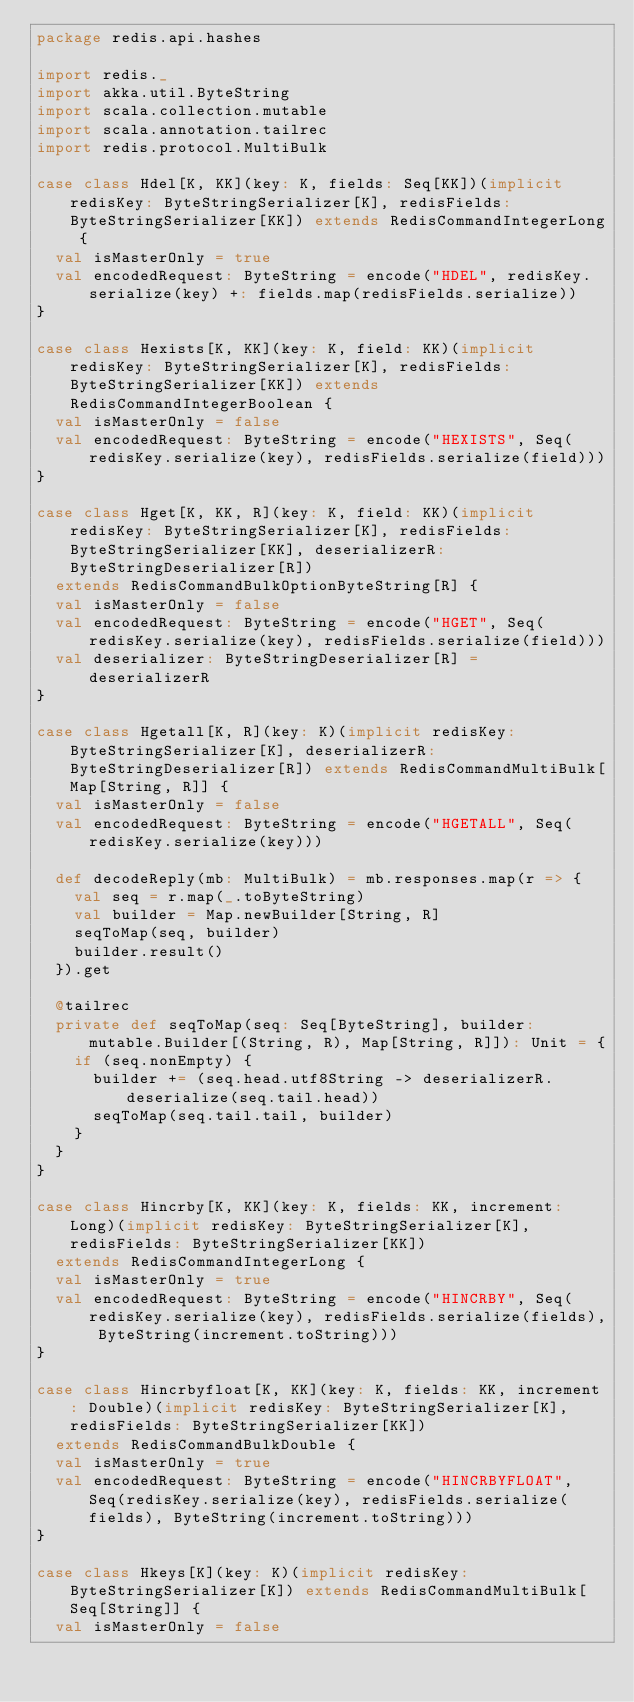<code> <loc_0><loc_0><loc_500><loc_500><_Scala_>package redis.api.hashes

import redis._
import akka.util.ByteString
import scala.collection.mutable
import scala.annotation.tailrec
import redis.protocol.MultiBulk

case class Hdel[K, KK](key: K, fields: Seq[KK])(implicit redisKey: ByteStringSerializer[K], redisFields: ByteStringSerializer[KK]) extends RedisCommandIntegerLong {
  val isMasterOnly = true
  val encodedRequest: ByteString = encode("HDEL", redisKey.serialize(key) +: fields.map(redisFields.serialize))
}

case class Hexists[K, KK](key: K, field: KK)(implicit redisKey: ByteStringSerializer[K], redisFields: ByteStringSerializer[KK]) extends RedisCommandIntegerBoolean {
  val isMasterOnly = false
  val encodedRequest: ByteString = encode("HEXISTS", Seq(redisKey.serialize(key), redisFields.serialize(field)))
}

case class Hget[K, KK, R](key: K, field: KK)(implicit redisKey: ByteStringSerializer[K], redisFields: ByteStringSerializer[KK], deserializerR: ByteStringDeserializer[R])
  extends RedisCommandBulkOptionByteString[R] {
  val isMasterOnly = false
  val encodedRequest: ByteString = encode("HGET", Seq(redisKey.serialize(key), redisFields.serialize(field)))
  val deserializer: ByteStringDeserializer[R] = deserializerR
}

case class Hgetall[K, R](key: K)(implicit redisKey: ByteStringSerializer[K], deserializerR: ByteStringDeserializer[R]) extends RedisCommandMultiBulk[Map[String, R]] {
  val isMasterOnly = false
  val encodedRequest: ByteString = encode("HGETALL", Seq(redisKey.serialize(key)))

  def decodeReply(mb: MultiBulk) = mb.responses.map(r => {
    val seq = r.map(_.toByteString)
    val builder = Map.newBuilder[String, R]
    seqToMap(seq, builder)
    builder.result()
  }).get

  @tailrec
  private def seqToMap(seq: Seq[ByteString], builder: mutable.Builder[(String, R), Map[String, R]]): Unit = {
    if (seq.nonEmpty) {
      builder += (seq.head.utf8String -> deserializerR.deserialize(seq.tail.head))
      seqToMap(seq.tail.tail, builder)
    }
  }
}

case class Hincrby[K, KK](key: K, fields: KK, increment: Long)(implicit redisKey: ByteStringSerializer[K], redisFields: ByteStringSerializer[KK])
  extends RedisCommandIntegerLong {
  val isMasterOnly = true
  val encodedRequest: ByteString = encode("HINCRBY", Seq(redisKey.serialize(key), redisFields.serialize(fields), ByteString(increment.toString)))
}

case class Hincrbyfloat[K, KK](key: K, fields: KK, increment: Double)(implicit redisKey: ByteStringSerializer[K], redisFields: ByteStringSerializer[KK])
  extends RedisCommandBulkDouble {
  val isMasterOnly = true
  val encodedRequest: ByteString = encode("HINCRBYFLOAT", Seq(redisKey.serialize(key), redisFields.serialize(fields), ByteString(increment.toString)))
}

case class Hkeys[K](key: K)(implicit redisKey: ByteStringSerializer[K]) extends RedisCommandMultiBulk[Seq[String]] {
  val isMasterOnly = false</code> 